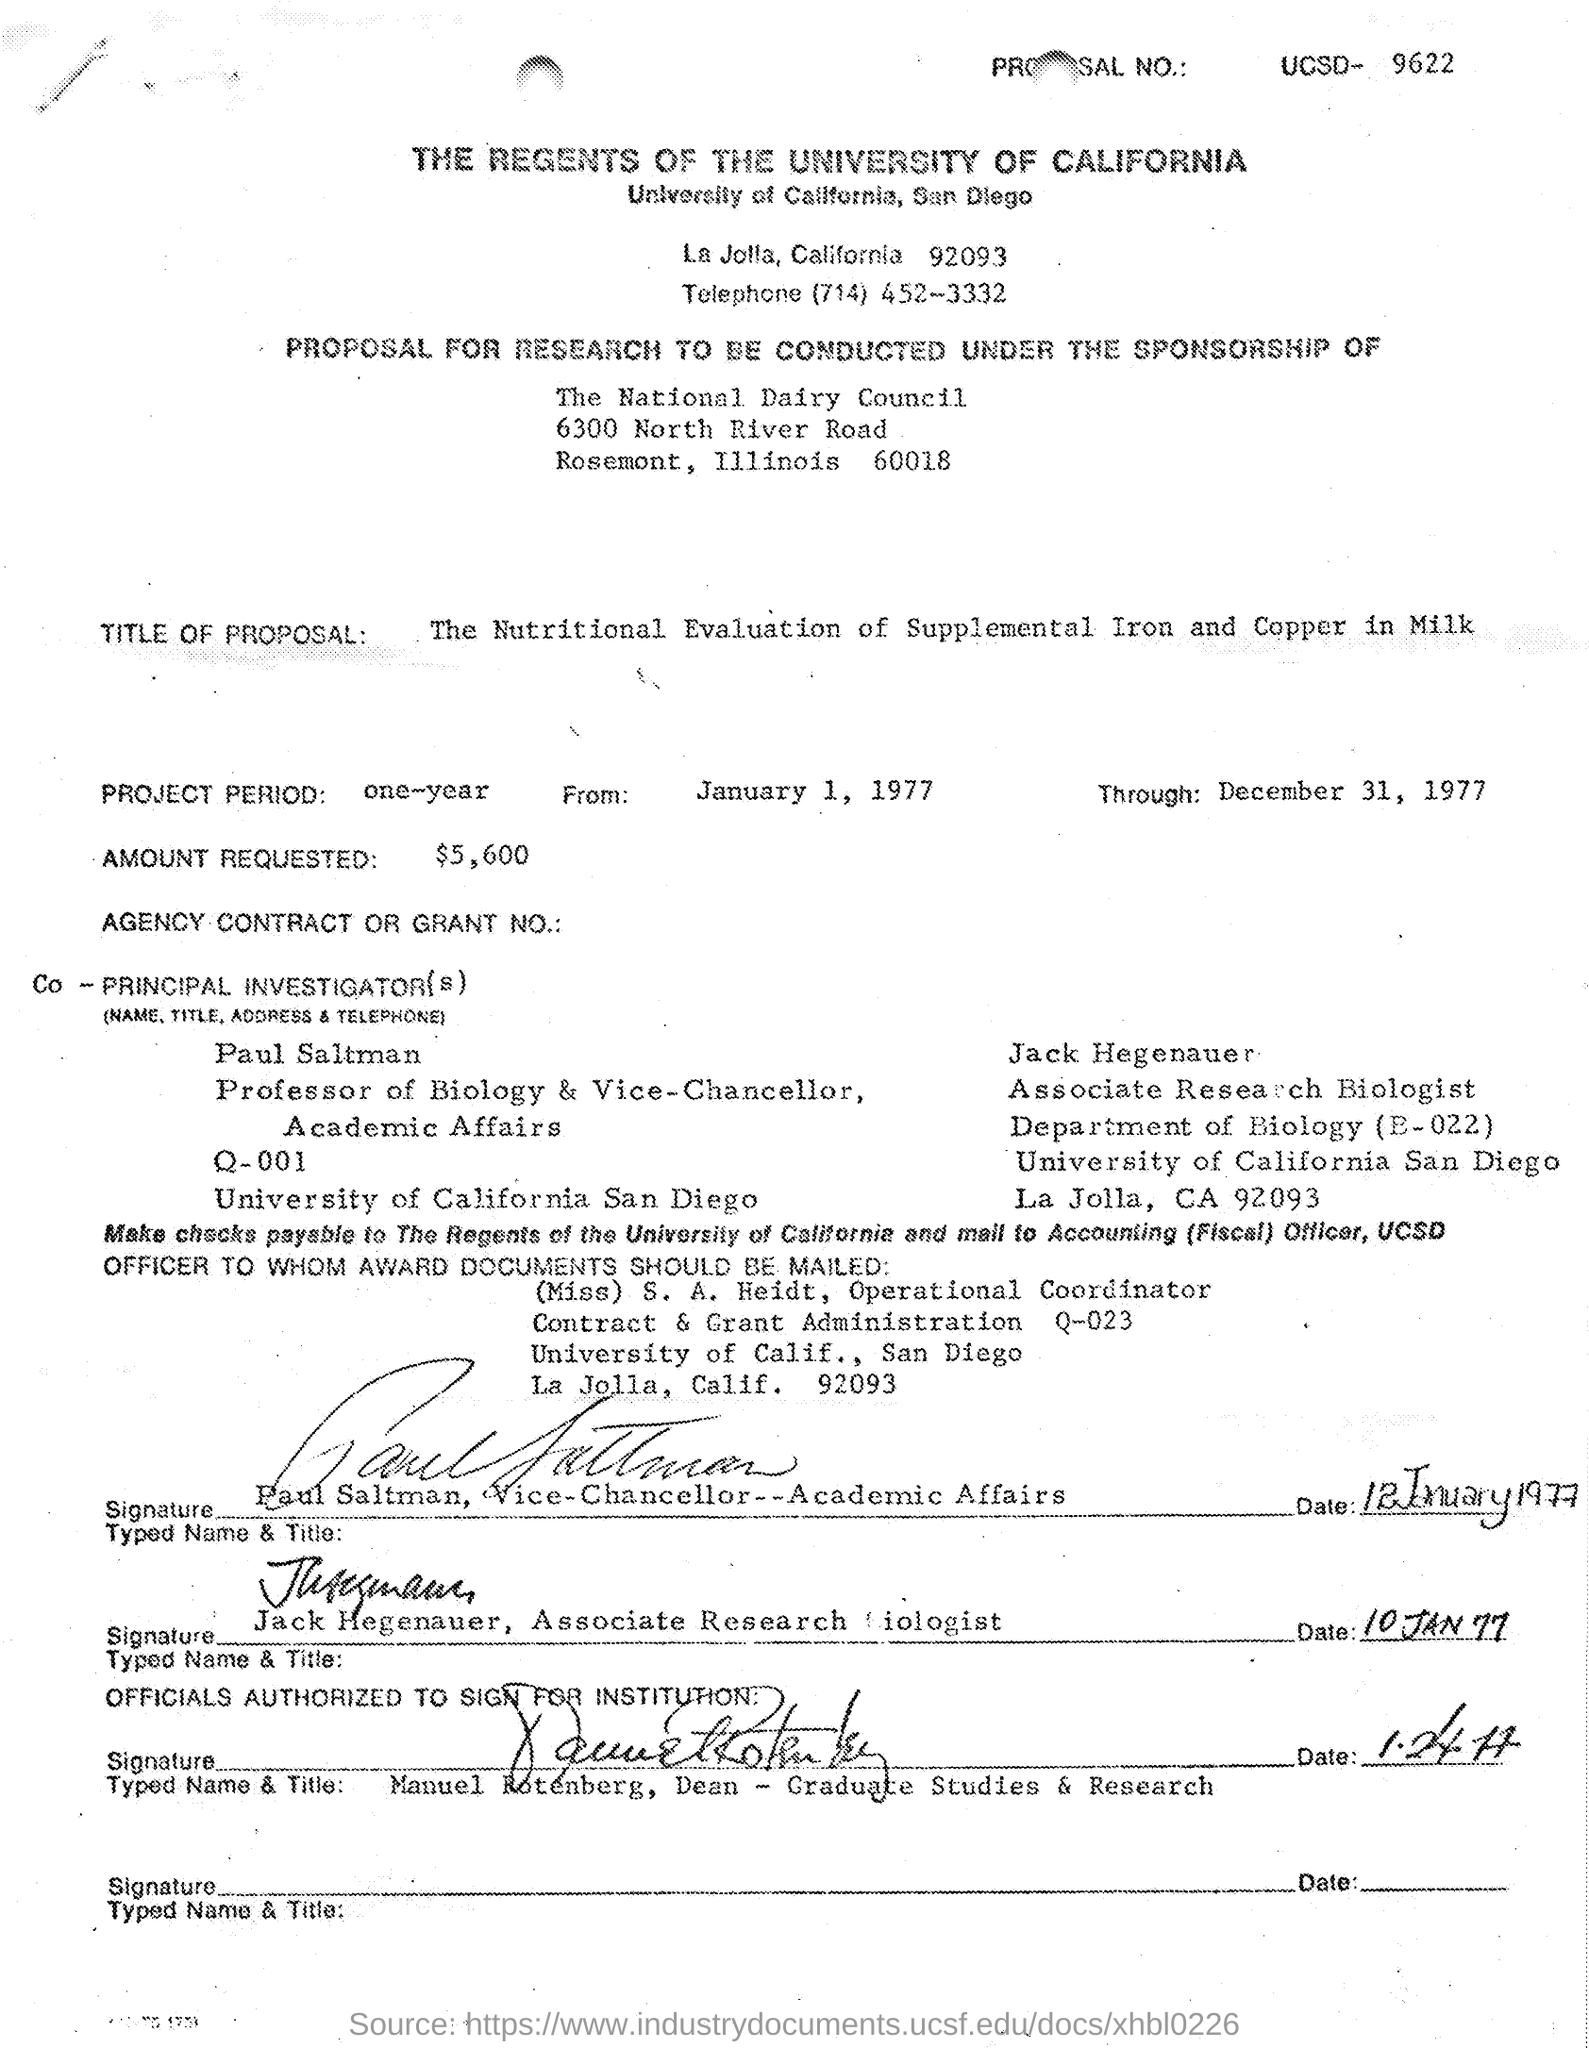Specify some key components in this picture. The amount requested is $5,600. The title of the proposal is 'The Nutritional Evaluation of Supplemental Iron and Copper in Milk.' The National Dairy Council is the sponsor of the research. 